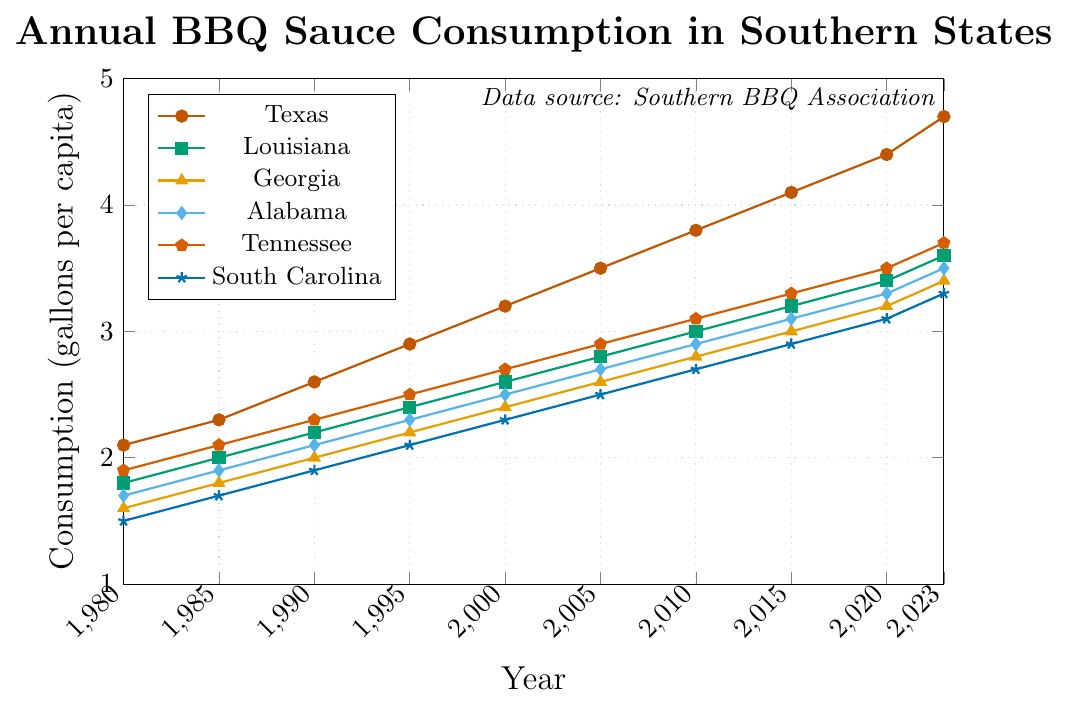What state had the highest BBQ sauce consumption in 2023? From the figure, Texas' line is the highest overall in 2023 compared to the lines representing the other states.
Answer: Texas Which state shows the smallest increase in BBQ sauce consumption from 1980 to 2023? By comparing the starting and ending points of all lines, South Carolina's increase from 1.5 in 1980 to 3.3 in 2023 is the smallest.
Answer: South Carolina How much did BBQ sauce consumption per capita increase in Texas from 2000 to 2020? In 2000, Texas' consumption was 3.2, and in 2020, it was 4.4. The increase is 4.4 - 3.2 = 1.2.
Answer: 1.2 Which state had the closest BBQ sauce consumption to Georgia in 1990? In 1990, Texas had 2.6, Louisiana had 2.2, Georgia had 2.0, Alabama had 2.1, Tennessee had 2.3, and South Carolina had 1.9. Alabama’s 2.1 is closest to Georgia's 2.0.
Answer: Alabama In which year did Louisiana first exceed 3.0 gallons per capita? By examining the Louisiana line, it first reaches 3.0 in 2010.
Answer: 2010 Which state experienced the greatest change in BBQ sauce consumption between 1990 and 1995? Texas' consumption rose from 2.6 to 2.9, Louisiana from 2.2 to 2.4, Georgia from 2.0 to 2.2, Alabama from 2.1 to 2.3, Tennessee from 2.3 to 2.5, and South Carolina from 1.9 to 2.1. All states had an increase of 0.2, so no state experienced a greater change.
Answer: None What's the average BBQ sauce consumption in Texas over the entire period (1980-2023)? The values for Texas are 2.1, 2.3, 2.6, 2.9, 3.2, 3.5, 3.8, 4.1, 4.4, 4.7. Summing these gives 33.6. Dividing by the 10 data points, the average is 33.6 / 10 = 3.36.
Answer: 3.36 Compare the trends of Texas and Alabama's BBQ sauce consumption from 2010 to 2023. Which state had a steeper increase? Texas' increase from 3.8 to 4.7 (0.9 increase), Alabama's increase from 2.9 to 3.5 (0.6 increase). Texas had a steeper increase.
Answer: Texas Which state had a more rapid increase in BBQ sauce consumption between 1980 and 1985, Georgia or Tennessee? Georgia’s consumption increased from 1.6 to 1.8 (+0.2), Tennessee from 1.9 to 2.1 (+0.2). Both states had the same increase.
Answer: Both What was the total BBQ sauce consumption of all states combined in 2023? Texas: 4.7, Louisiana: 3.6, Georgia: 3.4, Alabama: 3.5, Tennessee: 3.7, South Carolina: 3.3. Summing these: 4.7 + 3.6 + 3.4 + 3.5 + 3.7 + 3.3 = 22.2.
Answer: 22.2 